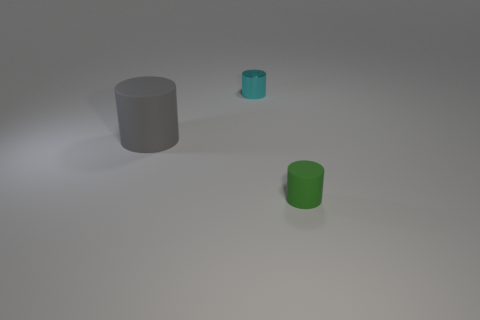There is a green object that is to the right of the cyan metallic object; what shape is it? cylinder 